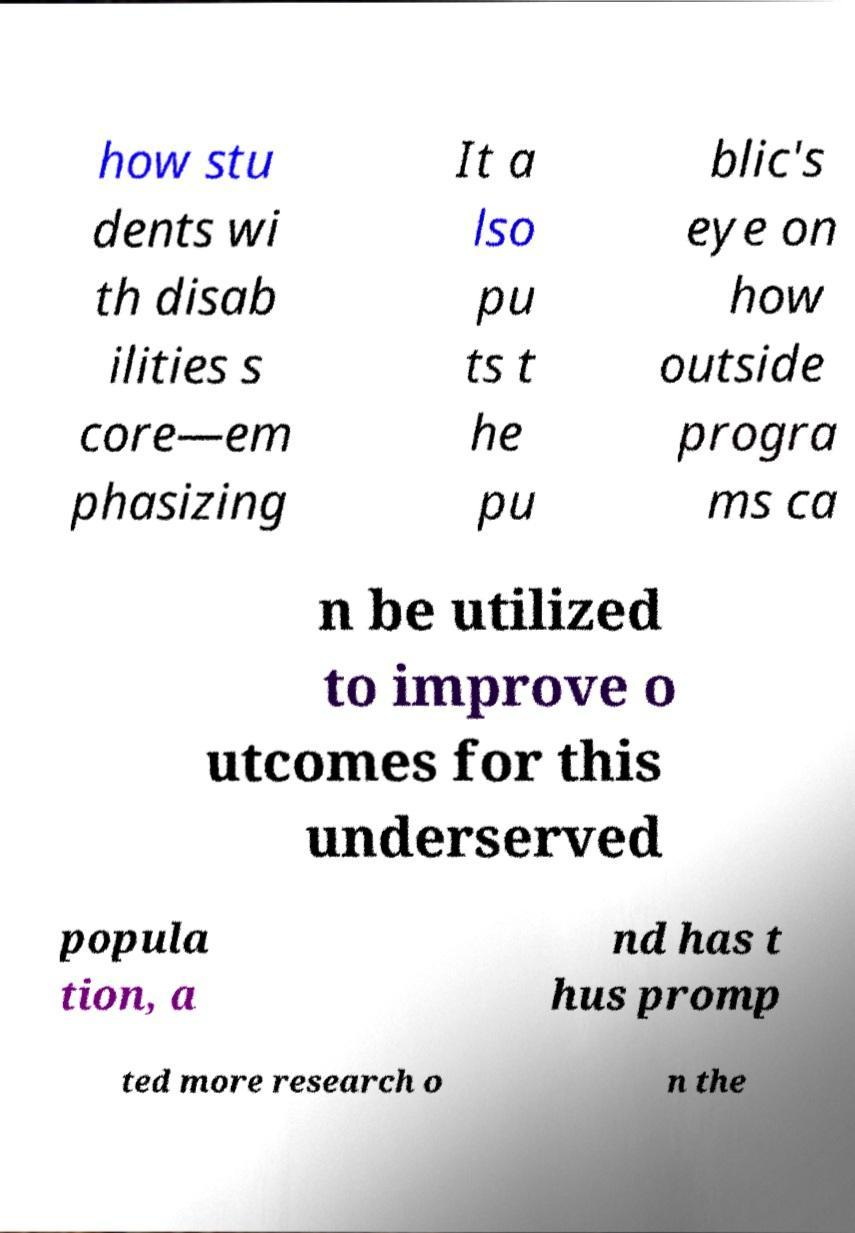Can you read and provide the text displayed in the image?This photo seems to have some interesting text. Can you extract and type it out for me? how stu dents wi th disab ilities s core—em phasizing It a lso pu ts t he pu blic's eye on how outside progra ms ca n be utilized to improve o utcomes for this underserved popula tion, a nd has t hus promp ted more research o n the 